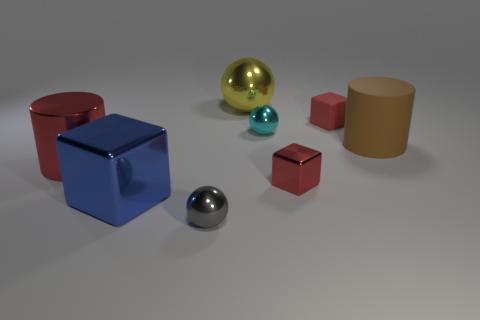How does lighting affect the appearance of the scene? The lighting casts soft shadows on the surface below the objects, suggesting a diffused light source. Highlights on the spheres and the reflective nature of the blue cube indicate the presence of a strong yet indirect light, adding dimensionality to the scene and emphasizing the textures of the objects. 